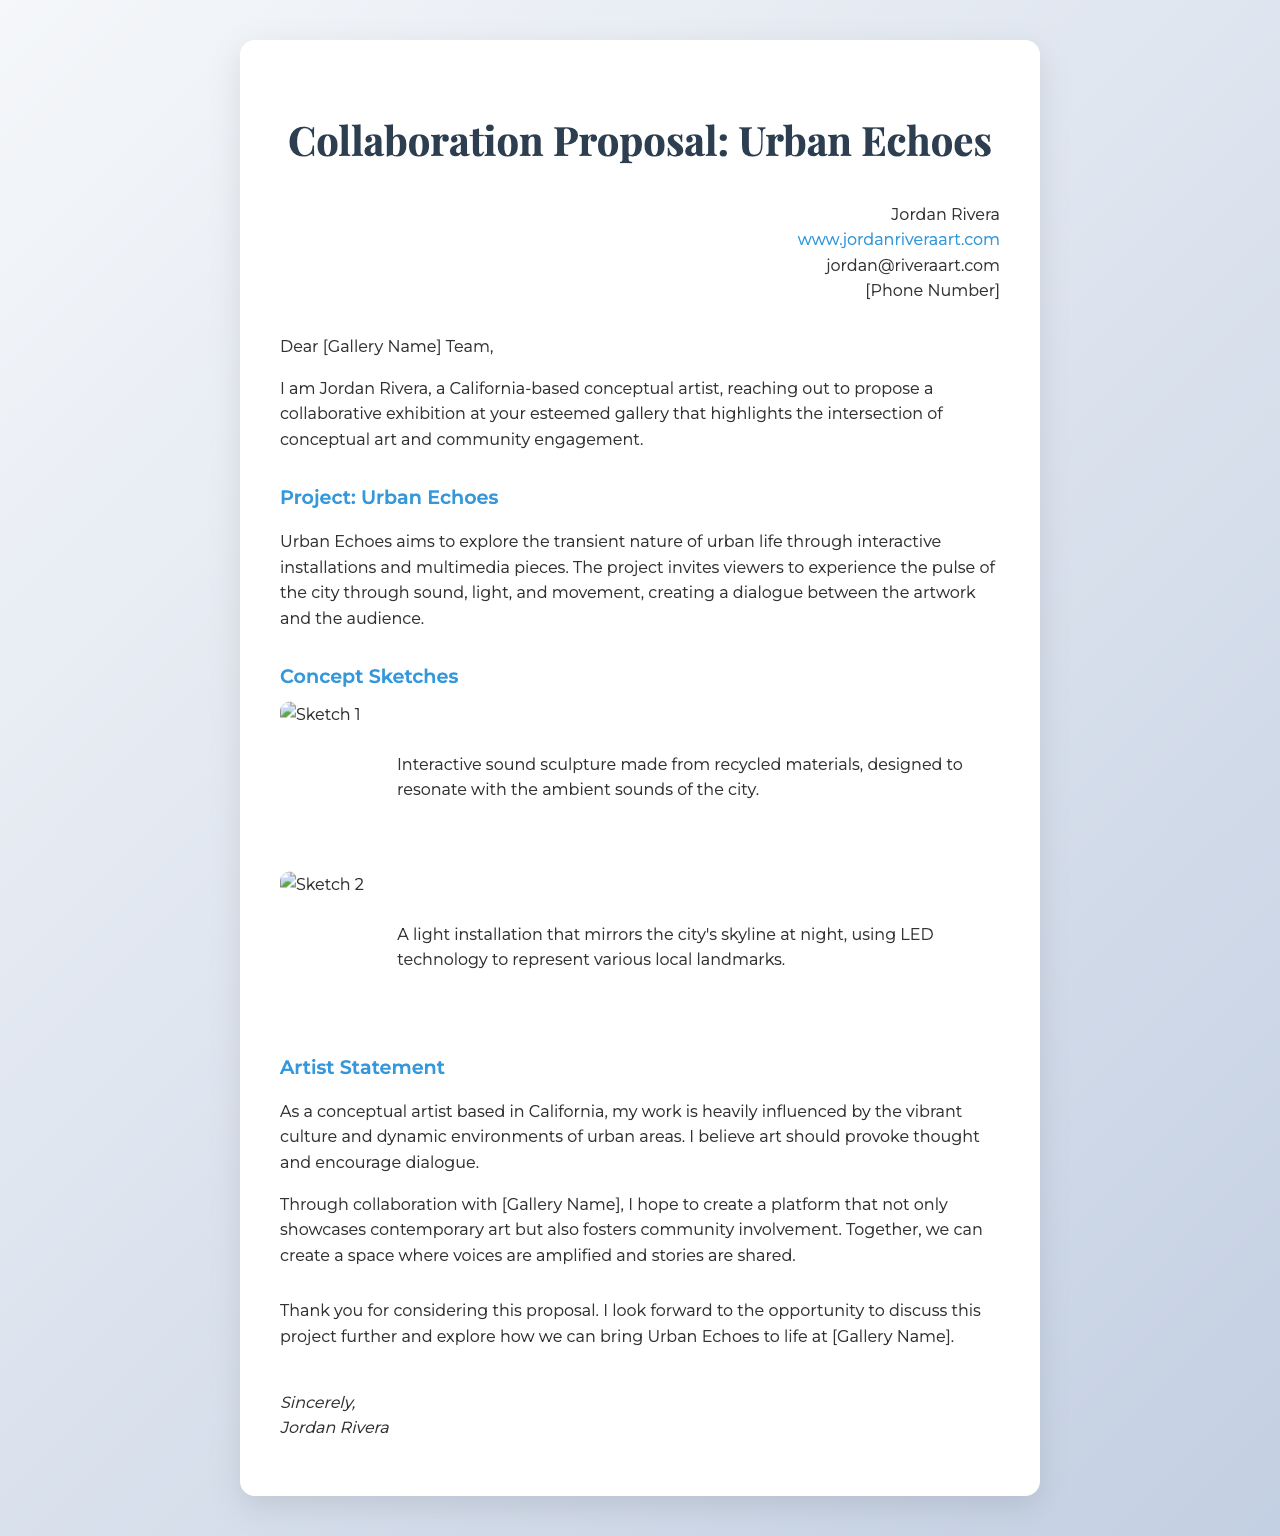What is the title of the project? The title of the project is mentioned as "Urban Echoes" in the document.
Answer: Urban Echoes Who is the artist proposing the collaboration? The artist proposing the collaboration is identified as Jordan Rivera.
Answer: Jordan Rivera What type of materials will be used for the interactive sound sculpture? The materials for the interactive sound sculpture are described as recycled materials.
Answer: Recycled materials What does the light installation represent? The light installation is mentioned to represent various local landmarks of the city.
Answer: Various local landmarks What is the primary theme of the project described? The primary theme is described as exploring the transient nature of urban life.
Answer: Transient nature of urban life What does the artist hope to foster through collaboration with the gallery? The artist hopes to foster community involvement through collaboration with the gallery.
Answer: Community involvement What is the artist's primary calling to action in the letter? The artist's calling to action is to discuss the project further and explore bringing Urban Echoes to life.
Answer: Discuss the project further How many concept sketches are included in the proposal? The document includes two concept sketches based on the visuals presented.
Answer: Two What color scheme is used in the document's background? The background features a gradient with shades of light gray and blue.
Answer: Light gray and blue 